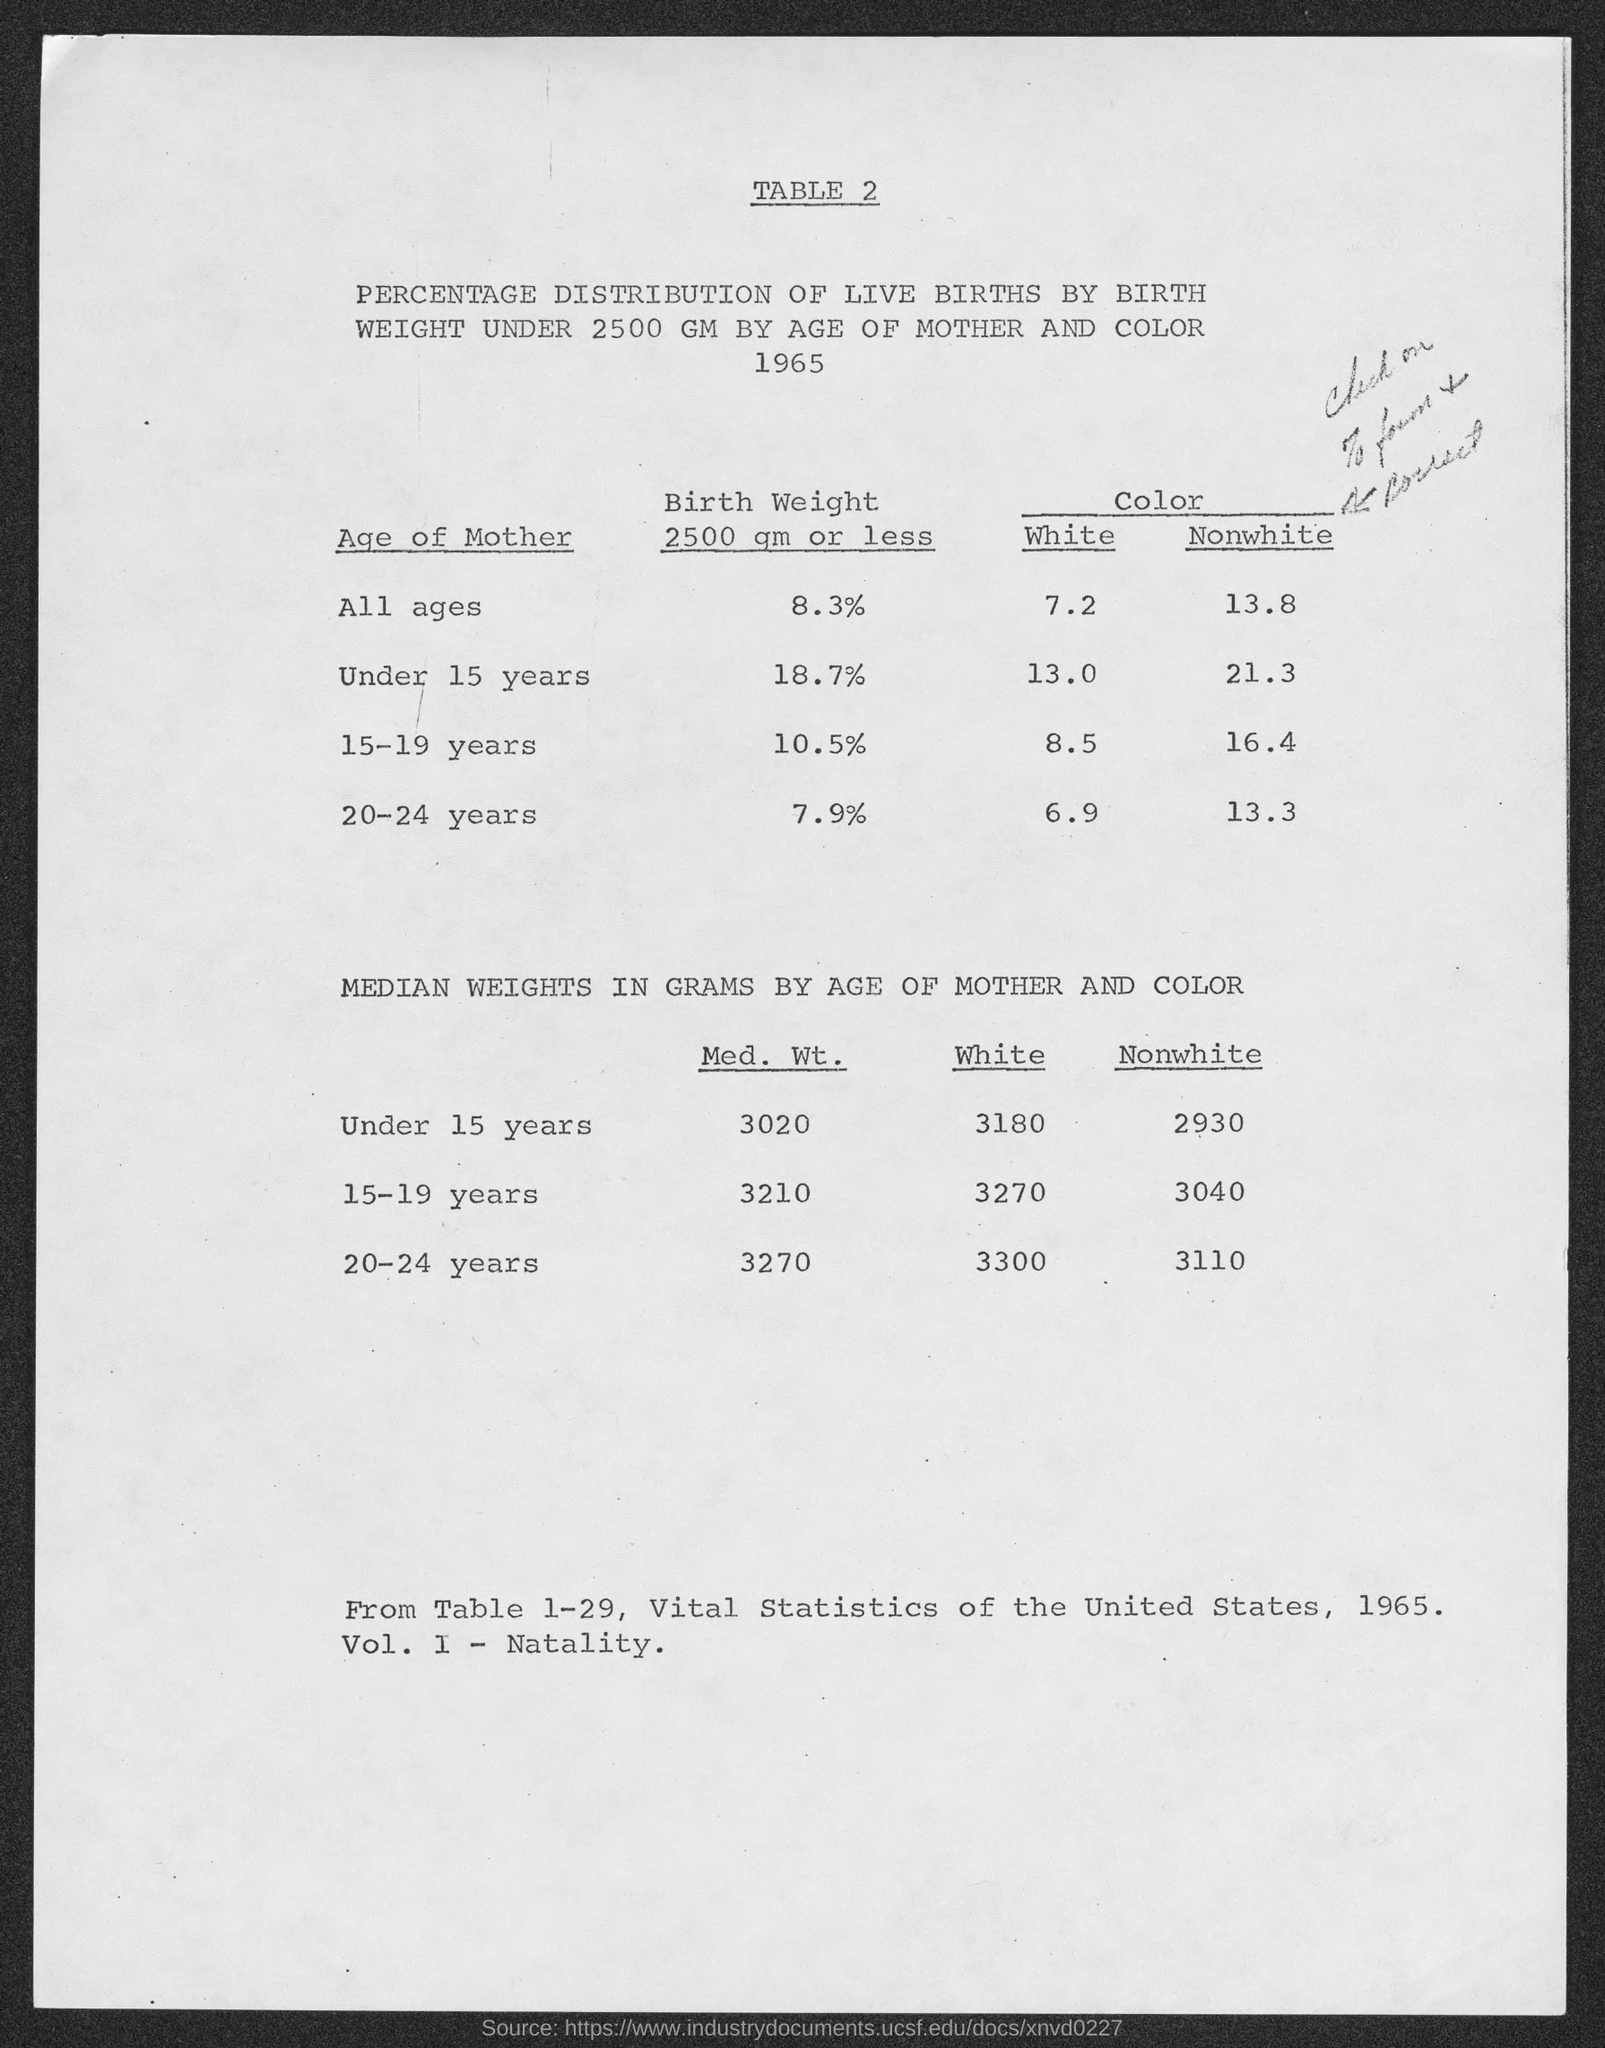What is the table number?
Ensure brevity in your answer.  2. What is the birth weight of mothers of all ages?
Give a very brief answer. 8 3%. 